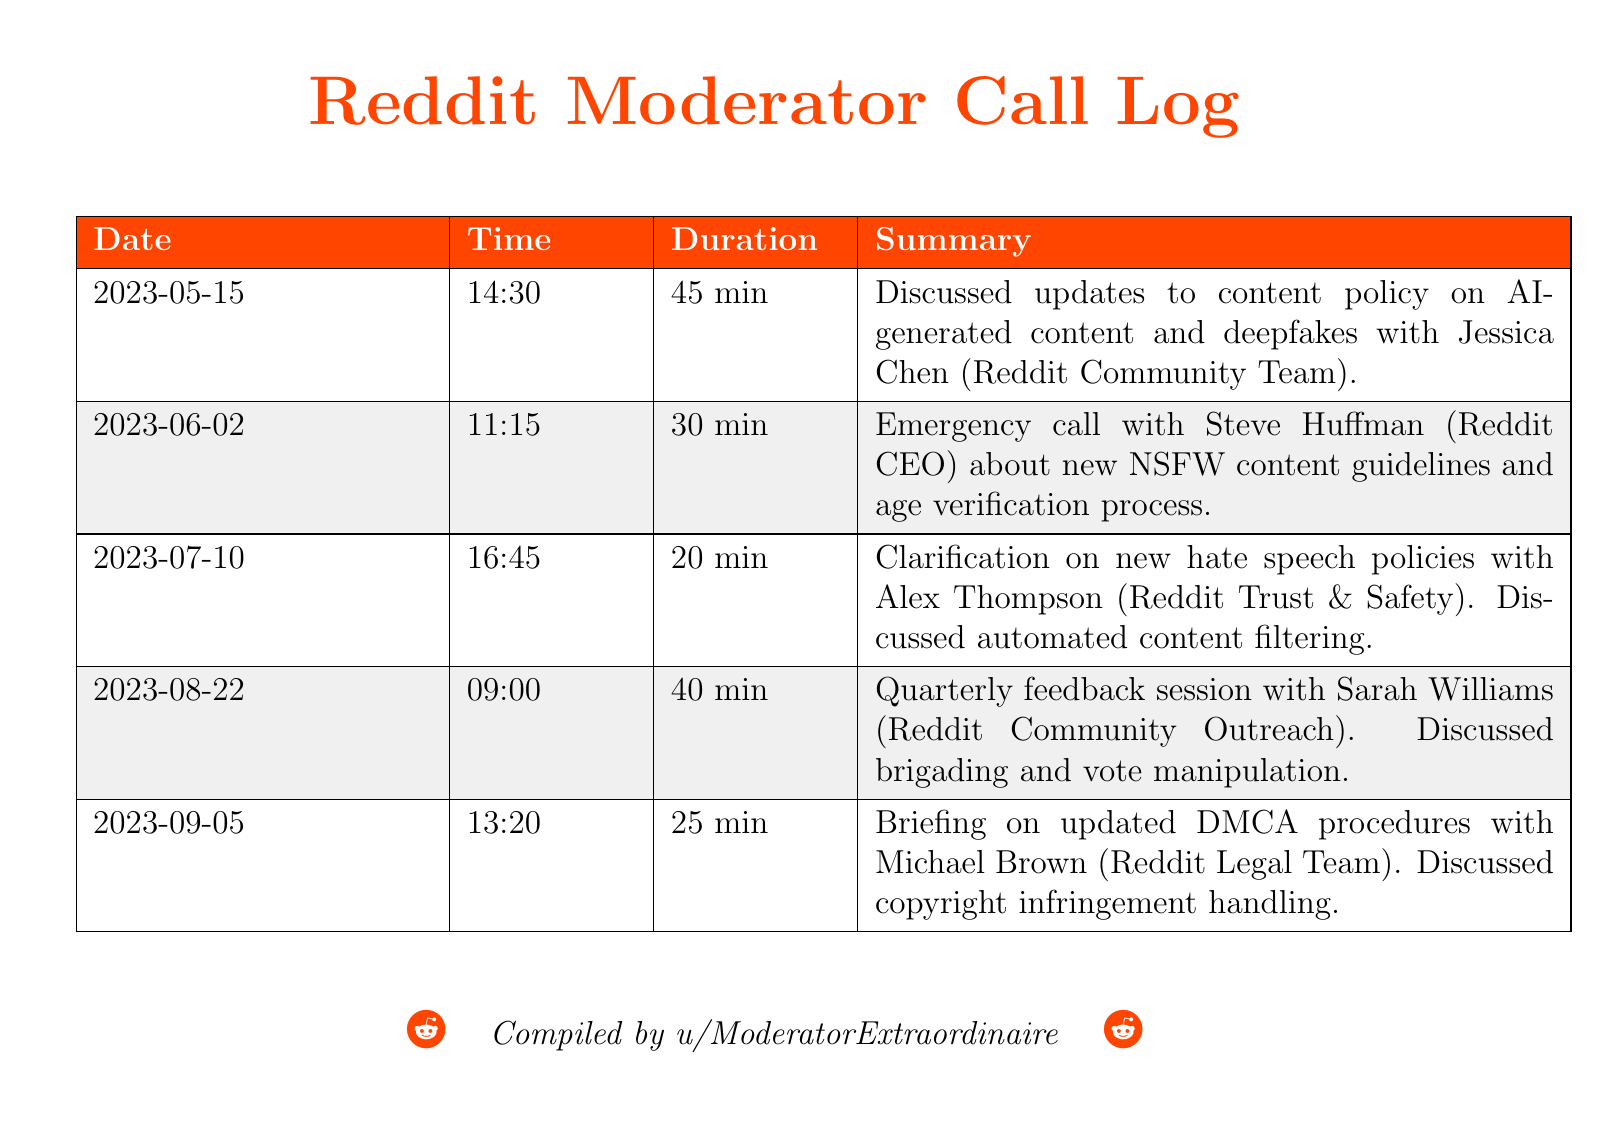What was discussed on May 15, 2023? The log states that updates to content policy on AI-generated content and deepfakes were discussed.
Answer: Updates to content policy on AI-generated content and deepfakes Who was involved in the emergency call on June 2, 2023? The document mentions that Steve Huffman, the Reddit CEO, was involved in the call.
Answer: Steve Huffman How long was the call with Alex Thompson? The duration of the call with Alex Thompson is listed as 20 minutes.
Answer: 20 min Which topics were discussed during the quarterly feedback session? The summary includes discussions on brigading and vote manipulation.
Answer: Brigading and vote manipulation What is the date of the briefing on DMCA procedures? The briefing on updated DMCA procedures took place on September 5, 2023.
Answer: 2023-09-05 What is the role of Jessica Chen according to the call log? She is identified as a member of the Reddit Community Team.
Answer: Reddit Community Team How many calls were made in total as per the log? There are five calls listed in the document.
Answer: Five Which content issues were addressed in the July 10 call? The call addressed new hate speech policies and automated content filtering.
Answer: New hate speech policies and automated content filtering What color is used for the document title? The color used for the title is Reddit Orange.
Answer: Reddit Orange 